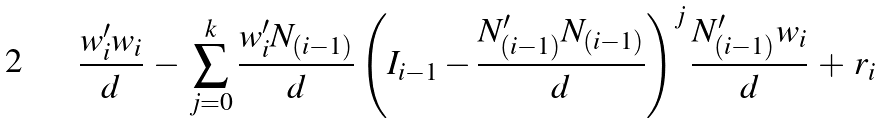<formula> <loc_0><loc_0><loc_500><loc_500>\frac { w _ { i } ^ { \prime } w _ { i } } { d } \, - \, \sum _ { j = 0 } ^ { k } \frac { w _ { i } ^ { \prime } N _ { ( i - 1 ) } } { d } \left ( I _ { i - 1 } - \frac { N _ { ( i - 1 ) } ^ { \prime } N _ { ( i - 1 ) } } { d } \right ) ^ { j } \frac { N _ { ( i - 1 ) } ^ { \prime } w _ { i } } { d } \, + \, r _ { i }</formula> 